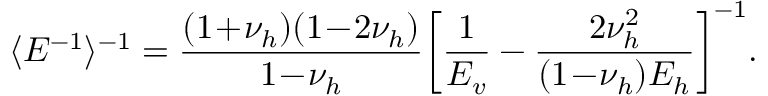<formula> <loc_0><loc_0><loc_500><loc_500>\langle E ^ { - 1 } \rangle ^ { - 1 } = \frac { ( 1 \, + \, \nu _ { h } ) ( 1 \, - \, 2 \nu _ { h } ) } { 1 \, - \, \nu _ { h } } \left [ \frac { 1 } { E _ { v } } - \frac { 2 \nu _ { h } ^ { 2 } } { ( 1 \, - \, \nu _ { h } ) E _ { h } } \right ] ^ { - 1 } .</formula> 